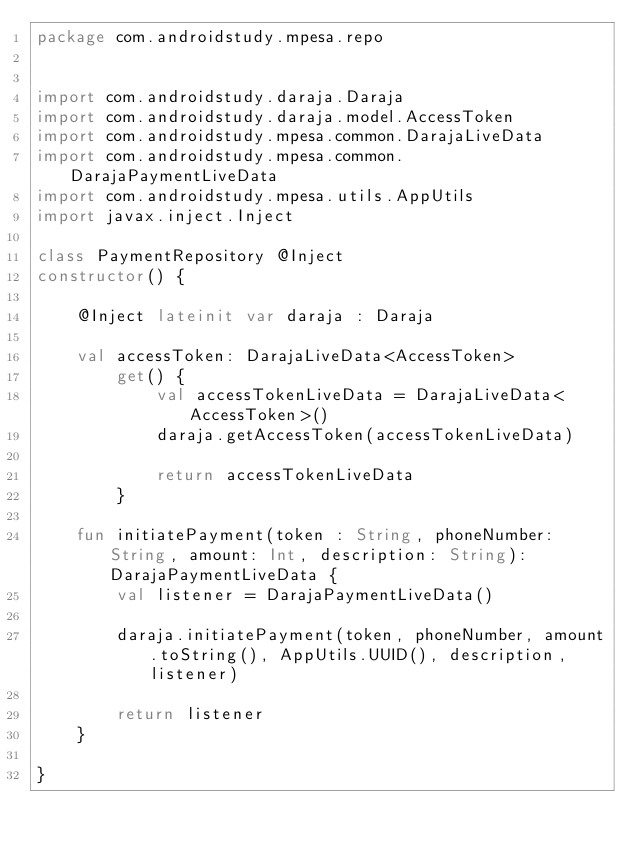Convert code to text. <code><loc_0><loc_0><loc_500><loc_500><_Kotlin_>package com.androidstudy.mpesa.repo


import com.androidstudy.daraja.Daraja
import com.androidstudy.daraja.model.AccessToken
import com.androidstudy.mpesa.common.DarajaLiveData
import com.androidstudy.mpesa.common.DarajaPaymentLiveData
import com.androidstudy.mpesa.utils.AppUtils
import javax.inject.Inject

class PaymentRepository @Inject
constructor() {

    @Inject lateinit var daraja : Daraja

    val accessToken: DarajaLiveData<AccessToken>
        get() {
            val accessTokenLiveData = DarajaLiveData<AccessToken>()
            daraja.getAccessToken(accessTokenLiveData)

            return accessTokenLiveData
        }

    fun initiatePayment(token : String, phoneNumber: String, amount: Int, description: String): DarajaPaymentLiveData {
        val listener = DarajaPaymentLiveData()

        daraja.initiatePayment(token, phoneNumber, amount.toString(), AppUtils.UUID(), description, listener)

        return listener
    }

}
</code> 